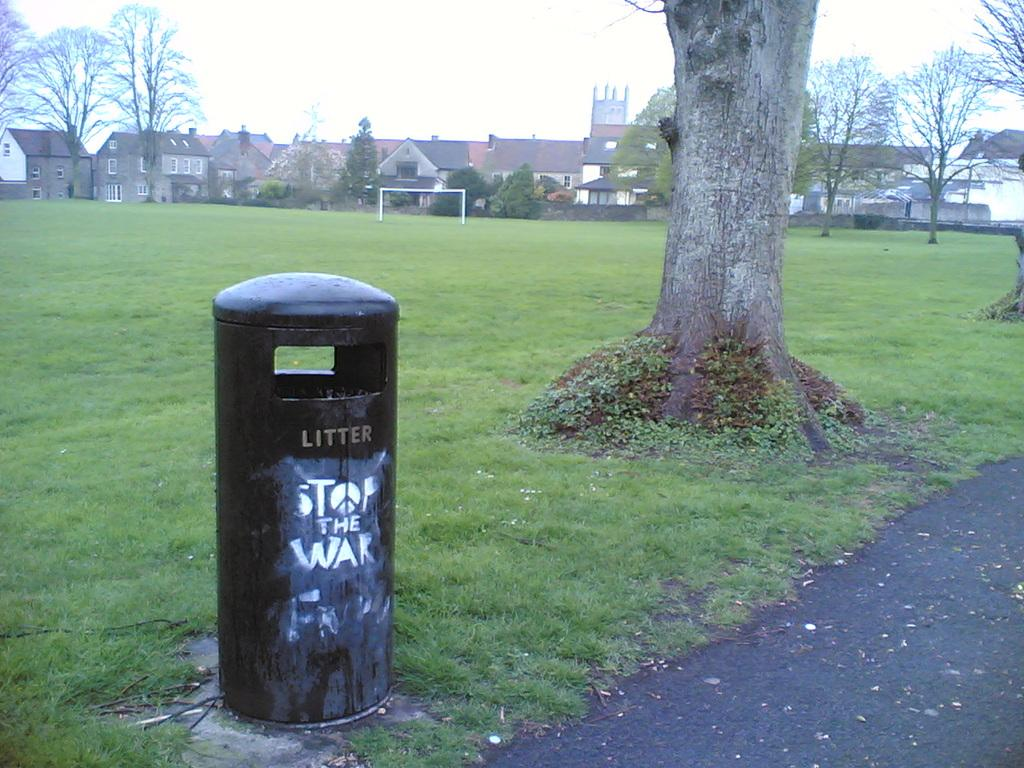<image>
Provide a brief description of the given image. A public trash can in the park with "Stop the War" drawn on it. 